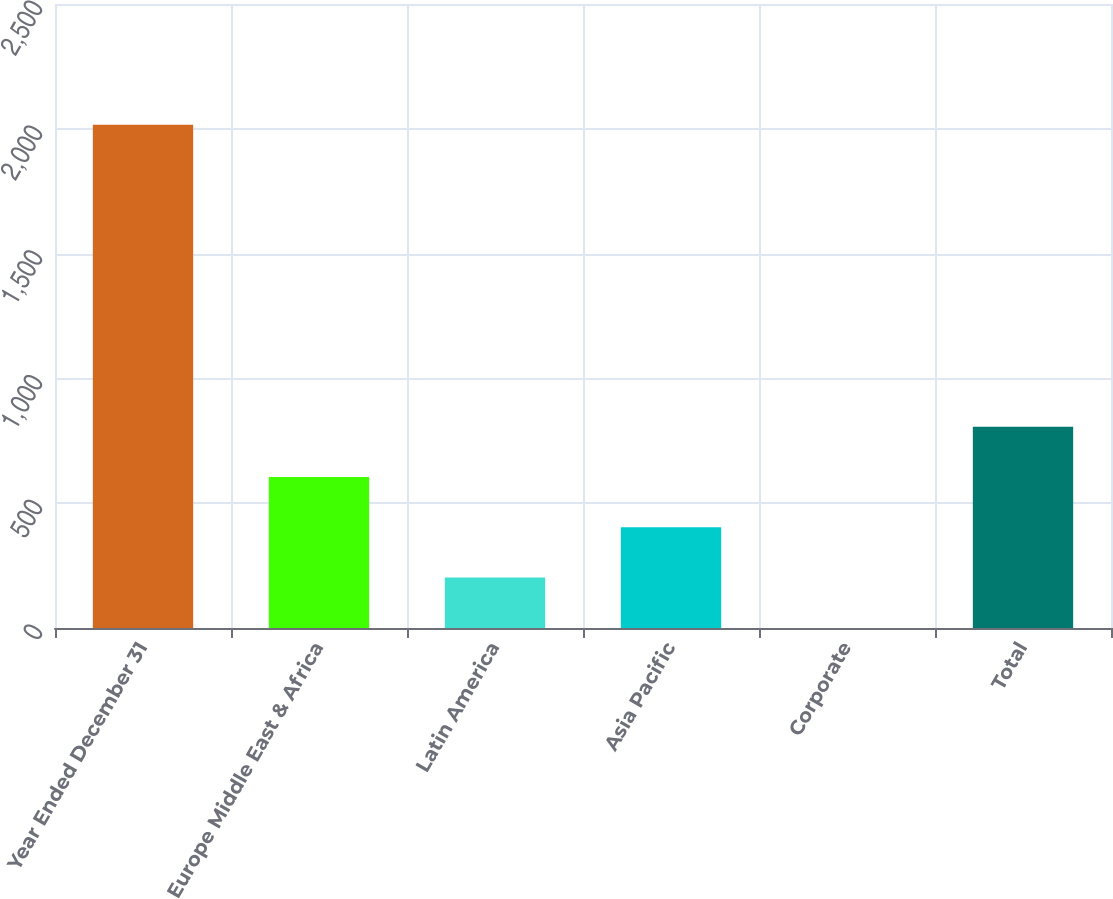Convert chart. <chart><loc_0><loc_0><loc_500><loc_500><bar_chart><fcel>Year Ended December 31<fcel>Europe Middle East & Africa<fcel>Latin America<fcel>Asia Pacific<fcel>Corporate<fcel>Total<nl><fcel>2016<fcel>605.01<fcel>201.87<fcel>403.44<fcel>0.3<fcel>806.58<nl></chart> 